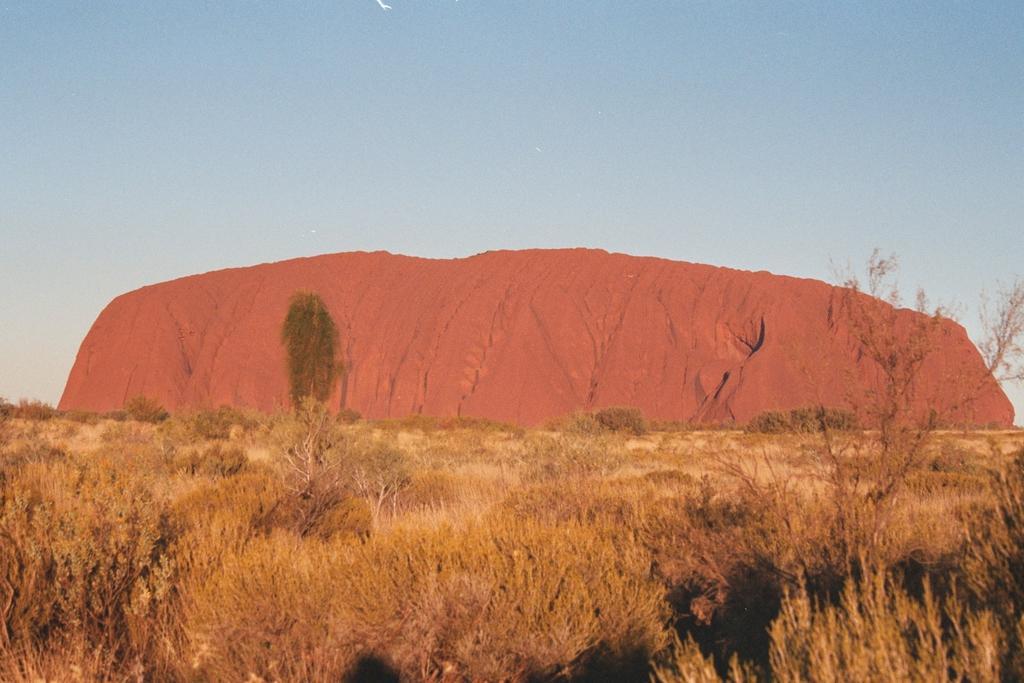How would you summarize this image in a sentence or two? In this picture we can see trees and in the background we can see sky. 